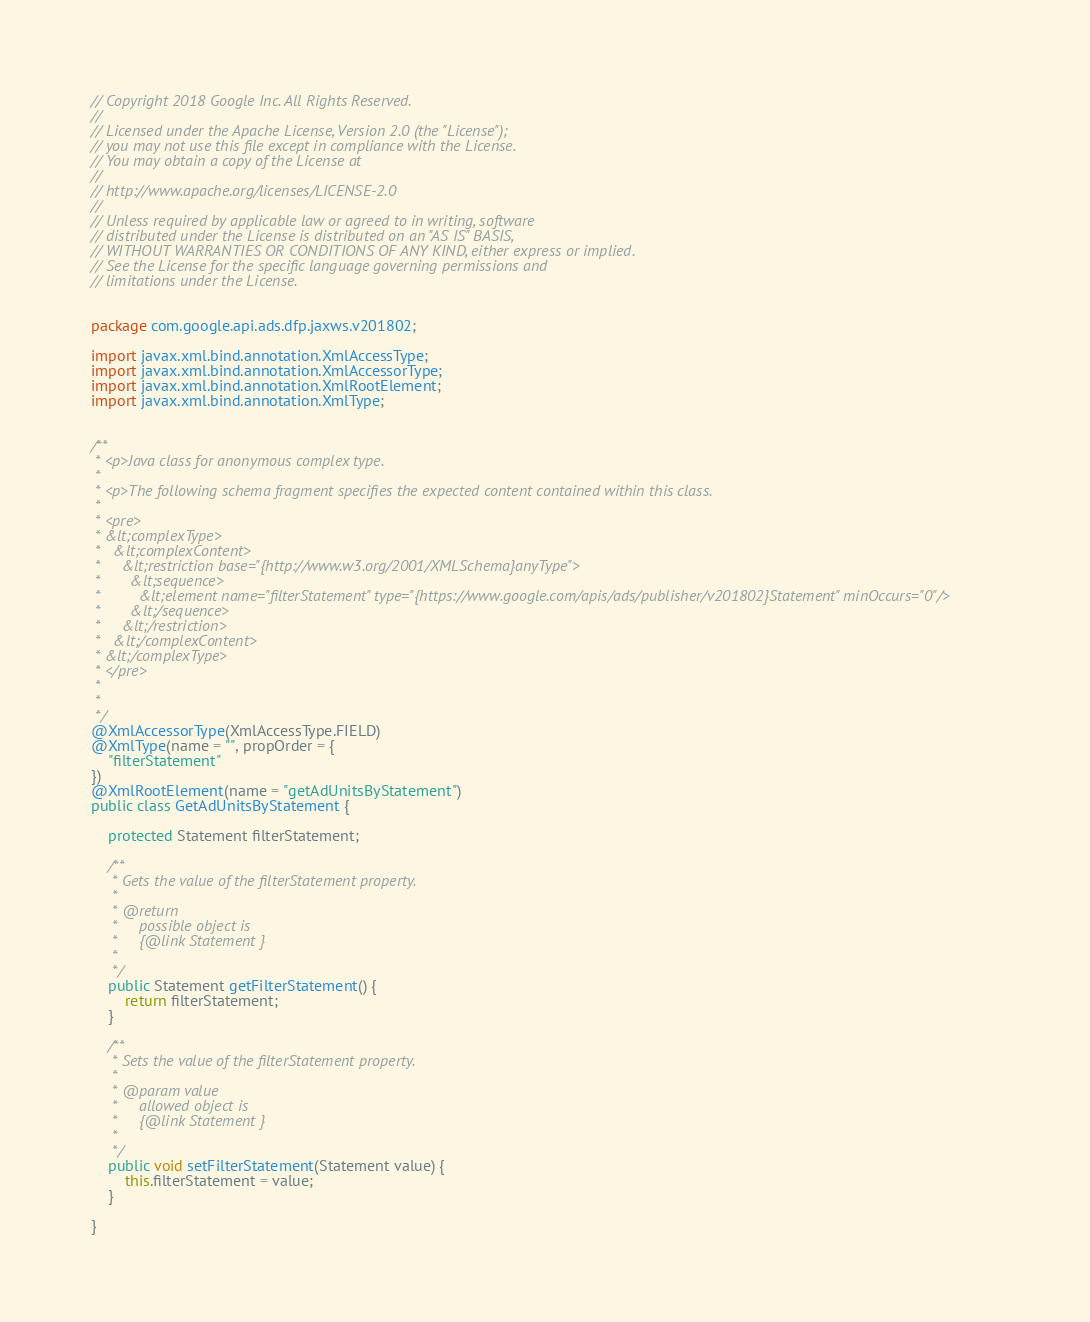Convert code to text. <code><loc_0><loc_0><loc_500><loc_500><_Java_>// Copyright 2018 Google Inc. All Rights Reserved.
//
// Licensed under the Apache License, Version 2.0 (the "License");
// you may not use this file except in compliance with the License.
// You may obtain a copy of the License at
//
// http://www.apache.org/licenses/LICENSE-2.0
//
// Unless required by applicable law or agreed to in writing, software
// distributed under the License is distributed on an "AS IS" BASIS,
// WITHOUT WARRANTIES OR CONDITIONS OF ANY KIND, either express or implied.
// See the License for the specific language governing permissions and
// limitations under the License.


package com.google.api.ads.dfp.jaxws.v201802;

import javax.xml.bind.annotation.XmlAccessType;
import javax.xml.bind.annotation.XmlAccessorType;
import javax.xml.bind.annotation.XmlRootElement;
import javax.xml.bind.annotation.XmlType;


/**
 * <p>Java class for anonymous complex type.
 * 
 * <p>The following schema fragment specifies the expected content contained within this class.
 * 
 * <pre>
 * &lt;complexType>
 *   &lt;complexContent>
 *     &lt;restriction base="{http://www.w3.org/2001/XMLSchema}anyType">
 *       &lt;sequence>
 *         &lt;element name="filterStatement" type="{https://www.google.com/apis/ads/publisher/v201802}Statement" minOccurs="0"/>
 *       &lt;/sequence>
 *     &lt;/restriction>
 *   &lt;/complexContent>
 * &lt;/complexType>
 * </pre>
 * 
 * 
 */
@XmlAccessorType(XmlAccessType.FIELD)
@XmlType(name = "", propOrder = {
    "filterStatement"
})
@XmlRootElement(name = "getAdUnitsByStatement")
public class GetAdUnitsByStatement {

    protected Statement filterStatement;

    /**
     * Gets the value of the filterStatement property.
     * 
     * @return
     *     possible object is
     *     {@link Statement }
     *     
     */
    public Statement getFilterStatement() {
        return filterStatement;
    }

    /**
     * Sets the value of the filterStatement property.
     * 
     * @param value
     *     allowed object is
     *     {@link Statement }
     *     
     */
    public void setFilterStatement(Statement value) {
        this.filterStatement = value;
    }

}
</code> 